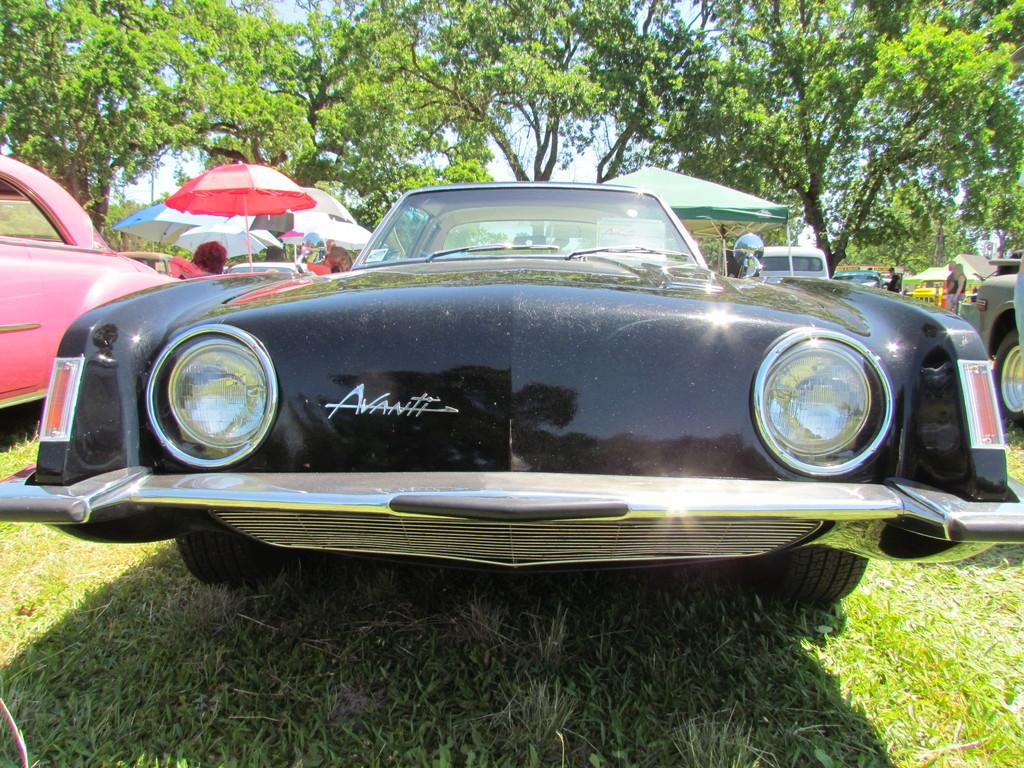What can be seen in the image? There are vehicles in the image. What is visible in the background of the image? In the background, there are umbrellas, stalls, trees, and the sky. What type of surface is visible in the image? There is grass visible in the image. What verse can be heard being recited by the bottle in the image? There is no bottle present in the image, and therefore no verse can be heard being recited. 